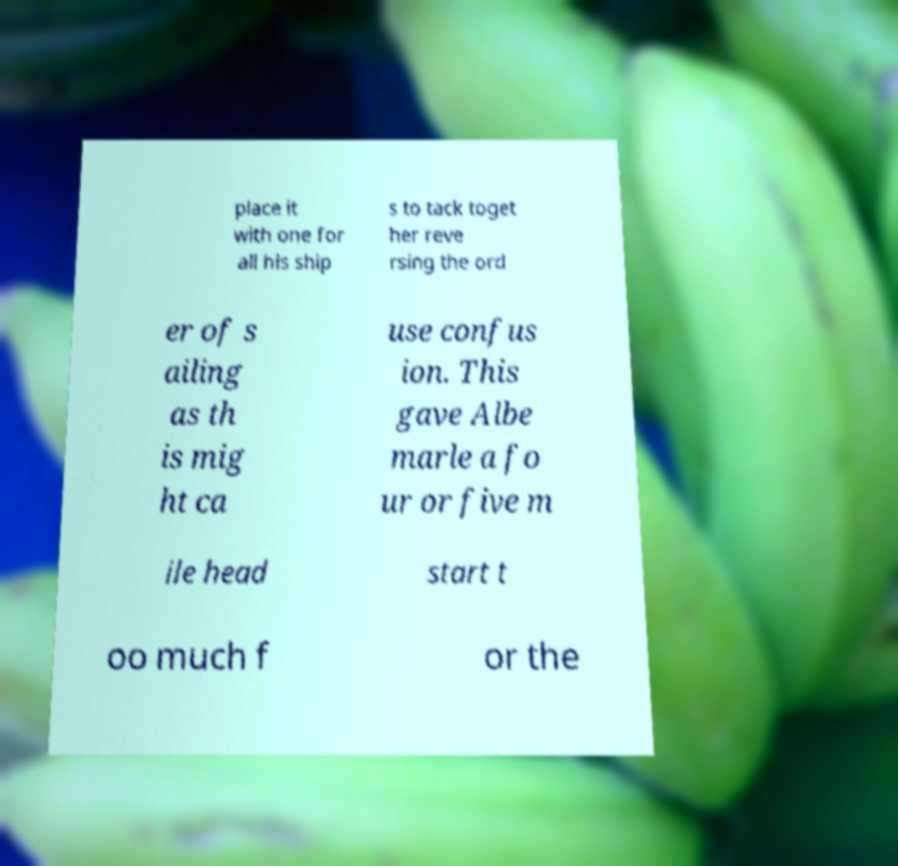What messages or text are displayed in this image? I need them in a readable, typed format. place it with one for all his ship s to tack toget her reve rsing the ord er of s ailing as th is mig ht ca use confus ion. This gave Albe marle a fo ur or five m ile head start t oo much f or the 